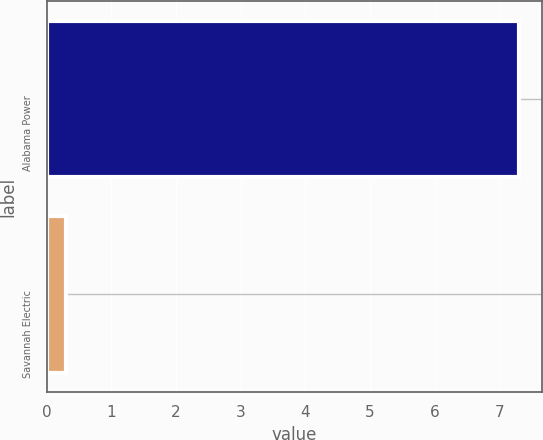Convert chart to OTSL. <chart><loc_0><loc_0><loc_500><loc_500><bar_chart><fcel>Alabama Power<fcel>Savannah Electric<nl><fcel>7.3<fcel>0.3<nl></chart> 